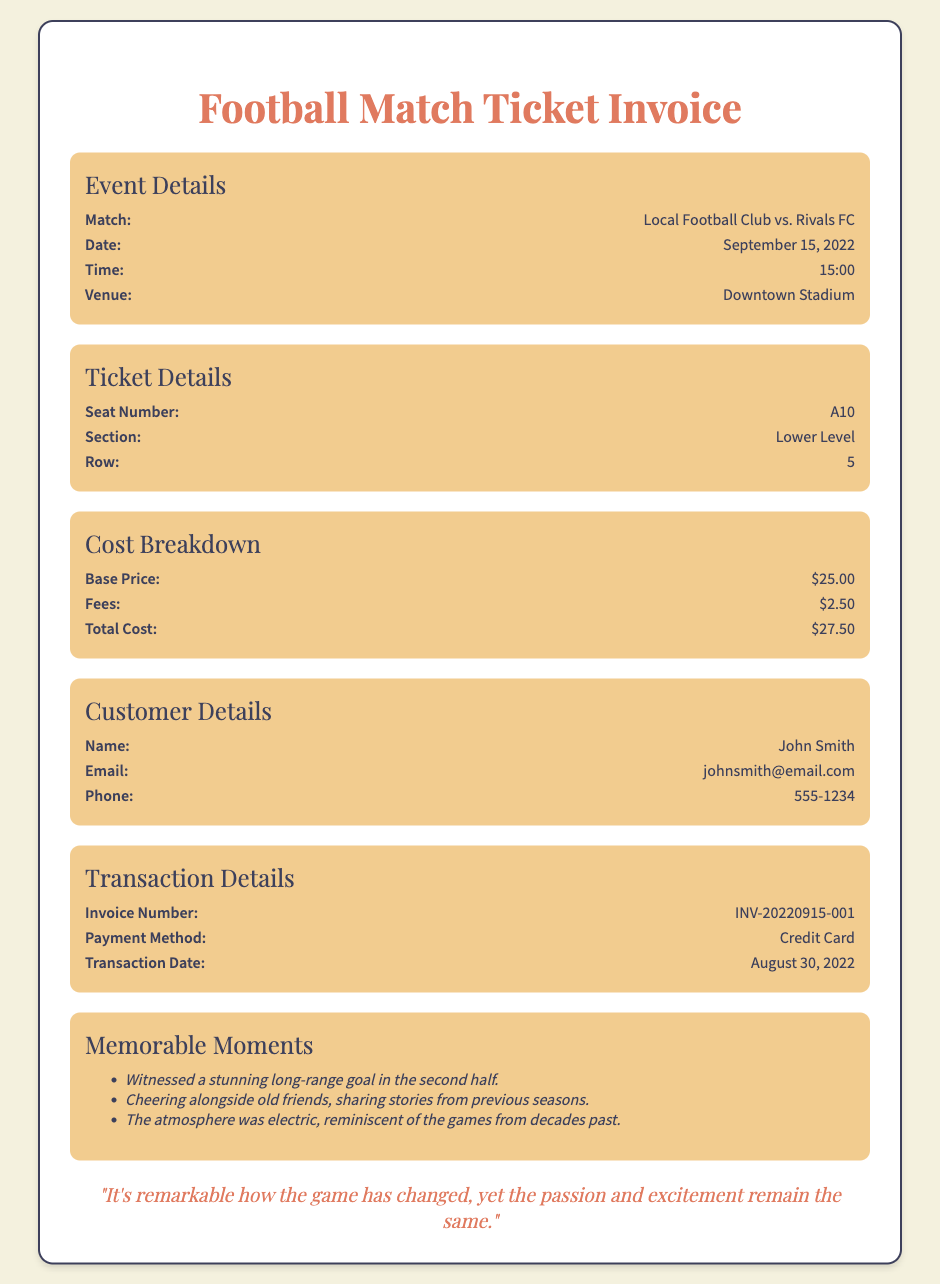What is the match's date? The date of the match is clearly stated in the document under Event Details.
Answer: September 15, 2022 What is the total cost of the ticket? The total cost is provided in the Cost Breakdown section of the document.
Answer: $27.50 What is the seat number for the ticket? The seat number is specified under Ticket Details in the document.
Answer: A10 What payment method was used? The payment method is mentioned in the Transaction Details section of the document.
Answer: Credit Card Who is the customer? The name of the customer is listed in the Customer Details section.
Answer: John Smith What is significant about the memorable moments? The Memorable Moments section recalls key experiences shared during the match, highlighting the game's atmosphere and personal connections.
Answer: Stunning long-range goal How does the invoice number start? The invoice number format is mentioned in the Transaction Details section.
Answer: INV-20220915-001 What section is the ticket located in? The section of the ticket is given under the Ticket Details heading in the document.
Answer: Lower Level 